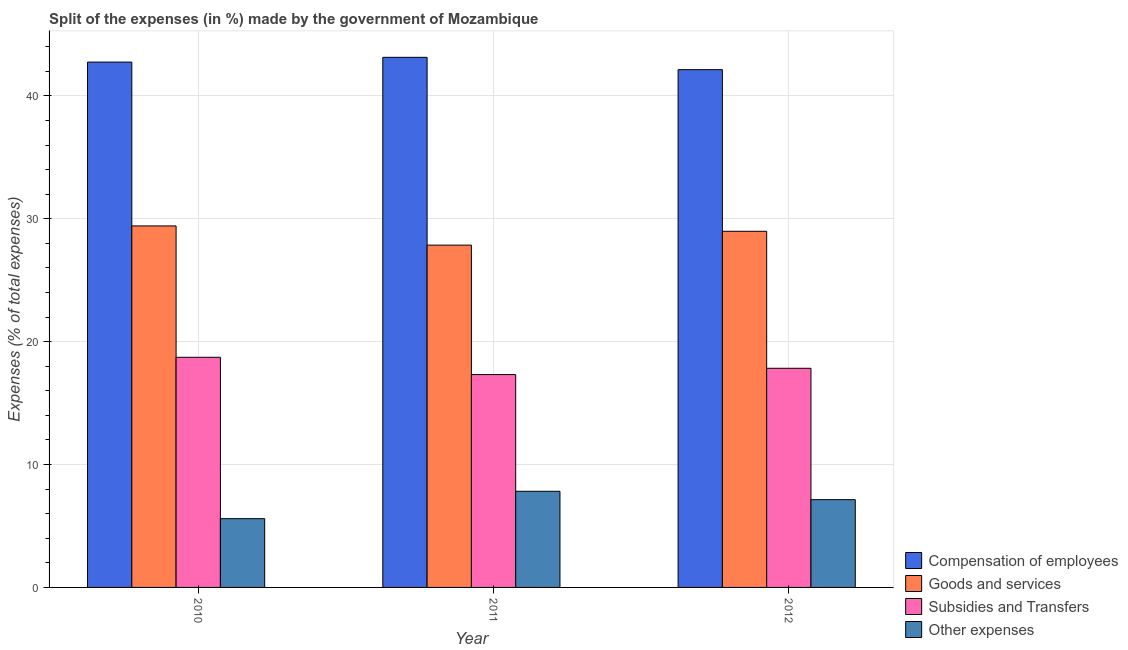How many groups of bars are there?
Keep it short and to the point. 3. Are the number of bars per tick equal to the number of legend labels?
Your answer should be compact. Yes. What is the label of the 1st group of bars from the left?
Provide a short and direct response. 2010. What is the percentage of amount spent on compensation of employees in 2012?
Keep it short and to the point. 42.13. Across all years, what is the maximum percentage of amount spent on subsidies?
Provide a succinct answer. 18.73. Across all years, what is the minimum percentage of amount spent on subsidies?
Your answer should be very brief. 17.32. In which year was the percentage of amount spent on subsidies maximum?
Provide a short and direct response. 2010. What is the total percentage of amount spent on other expenses in the graph?
Your answer should be very brief. 20.56. What is the difference between the percentage of amount spent on compensation of employees in 2010 and that in 2011?
Ensure brevity in your answer.  -0.39. What is the difference between the percentage of amount spent on subsidies in 2012 and the percentage of amount spent on goods and services in 2011?
Provide a succinct answer. 0.51. What is the average percentage of amount spent on subsidies per year?
Keep it short and to the point. 17.96. In how many years, is the percentage of amount spent on other expenses greater than 38 %?
Provide a succinct answer. 0. What is the ratio of the percentage of amount spent on subsidies in 2010 to that in 2012?
Provide a short and direct response. 1.05. Is the percentage of amount spent on subsidies in 2011 less than that in 2012?
Provide a succinct answer. Yes. What is the difference between the highest and the second highest percentage of amount spent on other expenses?
Your response must be concise. 0.68. What is the difference between the highest and the lowest percentage of amount spent on other expenses?
Your answer should be compact. 2.23. In how many years, is the percentage of amount spent on goods and services greater than the average percentage of amount spent on goods and services taken over all years?
Make the answer very short. 2. Is the sum of the percentage of amount spent on subsidies in 2010 and 2012 greater than the maximum percentage of amount spent on other expenses across all years?
Keep it short and to the point. Yes. What does the 4th bar from the left in 2011 represents?
Give a very brief answer. Other expenses. What does the 1st bar from the right in 2012 represents?
Your answer should be compact. Other expenses. How many years are there in the graph?
Provide a short and direct response. 3. Are the values on the major ticks of Y-axis written in scientific E-notation?
Your response must be concise. No. Does the graph contain grids?
Offer a terse response. Yes. Where does the legend appear in the graph?
Provide a short and direct response. Bottom right. How are the legend labels stacked?
Provide a short and direct response. Vertical. What is the title of the graph?
Offer a terse response. Split of the expenses (in %) made by the government of Mozambique. What is the label or title of the X-axis?
Ensure brevity in your answer.  Year. What is the label or title of the Y-axis?
Your response must be concise. Expenses (% of total expenses). What is the Expenses (% of total expenses) of Compensation of employees in 2010?
Offer a terse response. 42.75. What is the Expenses (% of total expenses) in Goods and services in 2010?
Your answer should be compact. 29.42. What is the Expenses (% of total expenses) of Subsidies and Transfers in 2010?
Your answer should be compact. 18.73. What is the Expenses (% of total expenses) of Other expenses in 2010?
Offer a very short reply. 5.6. What is the Expenses (% of total expenses) of Compensation of employees in 2011?
Provide a short and direct response. 43.13. What is the Expenses (% of total expenses) of Goods and services in 2011?
Make the answer very short. 27.85. What is the Expenses (% of total expenses) in Subsidies and Transfers in 2011?
Your answer should be very brief. 17.32. What is the Expenses (% of total expenses) of Other expenses in 2011?
Keep it short and to the point. 7.82. What is the Expenses (% of total expenses) in Compensation of employees in 2012?
Give a very brief answer. 42.13. What is the Expenses (% of total expenses) in Goods and services in 2012?
Your response must be concise. 28.98. What is the Expenses (% of total expenses) in Subsidies and Transfers in 2012?
Offer a terse response. 17.83. What is the Expenses (% of total expenses) of Other expenses in 2012?
Keep it short and to the point. 7.14. Across all years, what is the maximum Expenses (% of total expenses) in Compensation of employees?
Provide a succinct answer. 43.13. Across all years, what is the maximum Expenses (% of total expenses) in Goods and services?
Keep it short and to the point. 29.42. Across all years, what is the maximum Expenses (% of total expenses) of Subsidies and Transfers?
Keep it short and to the point. 18.73. Across all years, what is the maximum Expenses (% of total expenses) in Other expenses?
Offer a terse response. 7.82. Across all years, what is the minimum Expenses (% of total expenses) of Compensation of employees?
Give a very brief answer. 42.13. Across all years, what is the minimum Expenses (% of total expenses) in Goods and services?
Offer a very short reply. 27.85. Across all years, what is the minimum Expenses (% of total expenses) of Subsidies and Transfers?
Offer a very short reply. 17.32. Across all years, what is the minimum Expenses (% of total expenses) of Other expenses?
Provide a short and direct response. 5.6. What is the total Expenses (% of total expenses) in Compensation of employees in the graph?
Your answer should be very brief. 128.01. What is the total Expenses (% of total expenses) of Goods and services in the graph?
Provide a succinct answer. 86.25. What is the total Expenses (% of total expenses) of Subsidies and Transfers in the graph?
Your answer should be very brief. 53.88. What is the total Expenses (% of total expenses) of Other expenses in the graph?
Your response must be concise. 20.56. What is the difference between the Expenses (% of total expenses) in Compensation of employees in 2010 and that in 2011?
Keep it short and to the point. -0.39. What is the difference between the Expenses (% of total expenses) of Goods and services in 2010 and that in 2011?
Your response must be concise. 1.56. What is the difference between the Expenses (% of total expenses) in Subsidies and Transfers in 2010 and that in 2011?
Offer a very short reply. 1.41. What is the difference between the Expenses (% of total expenses) in Other expenses in 2010 and that in 2011?
Offer a very short reply. -2.23. What is the difference between the Expenses (% of total expenses) in Compensation of employees in 2010 and that in 2012?
Offer a terse response. 0.62. What is the difference between the Expenses (% of total expenses) in Goods and services in 2010 and that in 2012?
Ensure brevity in your answer.  0.44. What is the difference between the Expenses (% of total expenses) in Subsidies and Transfers in 2010 and that in 2012?
Your answer should be compact. 0.89. What is the difference between the Expenses (% of total expenses) of Other expenses in 2010 and that in 2012?
Provide a succinct answer. -1.55. What is the difference between the Expenses (% of total expenses) of Goods and services in 2011 and that in 2012?
Your answer should be compact. -1.13. What is the difference between the Expenses (% of total expenses) in Subsidies and Transfers in 2011 and that in 2012?
Your response must be concise. -0.51. What is the difference between the Expenses (% of total expenses) of Other expenses in 2011 and that in 2012?
Your answer should be very brief. 0.68. What is the difference between the Expenses (% of total expenses) in Compensation of employees in 2010 and the Expenses (% of total expenses) in Goods and services in 2011?
Your response must be concise. 14.89. What is the difference between the Expenses (% of total expenses) of Compensation of employees in 2010 and the Expenses (% of total expenses) of Subsidies and Transfers in 2011?
Offer a very short reply. 25.43. What is the difference between the Expenses (% of total expenses) in Compensation of employees in 2010 and the Expenses (% of total expenses) in Other expenses in 2011?
Your answer should be compact. 34.92. What is the difference between the Expenses (% of total expenses) of Goods and services in 2010 and the Expenses (% of total expenses) of Subsidies and Transfers in 2011?
Your answer should be very brief. 12.1. What is the difference between the Expenses (% of total expenses) in Goods and services in 2010 and the Expenses (% of total expenses) in Other expenses in 2011?
Provide a succinct answer. 21.59. What is the difference between the Expenses (% of total expenses) in Subsidies and Transfers in 2010 and the Expenses (% of total expenses) in Other expenses in 2011?
Ensure brevity in your answer.  10.9. What is the difference between the Expenses (% of total expenses) in Compensation of employees in 2010 and the Expenses (% of total expenses) in Goods and services in 2012?
Your answer should be very brief. 13.77. What is the difference between the Expenses (% of total expenses) of Compensation of employees in 2010 and the Expenses (% of total expenses) of Subsidies and Transfers in 2012?
Ensure brevity in your answer.  24.92. What is the difference between the Expenses (% of total expenses) in Compensation of employees in 2010 and the Expenses (% of total expenses) in Other expenses in 2012?
Make the answer very short. 35.61. What is the difference between the Expenses (% of total expenses) of Goods and services in 2010 and the Expenses (% of total expenses) of Subsidies and Transfers in 2012?
Provide a succinct answer. 11.58. What is the difference between the Expenses (% of total expenses) of Goods and services in 2010 and the Expenses (% of total expenses) of Other expenses in 2012?
Offer a terse response. 22.27. What is the difference between the Expenses (% of total expenses) in Subsidies and Transfers in 2010 and the Expenses (% of total expenses) in Other expenses in 2012?
Give a very brief answer. 11.59. What is the difference between the Expenses (% of total expenses) of Compensation of employees in 2011 and the Expenses (% of total expenses) of Goods and services in 2012?
Offer a terse response. 14.15. What is the difference between the Expenses (% of total expenses) of Compensation of employees in 2011 and the Expenses (% of total expenses) of Subsidies and Transfers in 2012?
Provide a short and direct response. 25.3. What is the difference between the Expenses (% of total expenses) in Compensation of employees in 2011 and the Expenses (% of total expenses) in Other expenses in 2012?
Offer a terse response. 35.99. What is the difference between the Expenses (% of total expenses) in Goods and services in 2011 and the Expenses (% of total expenses) in Subsidies and Transfers in 2012?
Make the answer very short. 10.02. What is the difference between the Expenses (% of total expenses) of Goods and services in 2011 and the Expenses (% of total expenses) of Other expenses in 2012?
Make the answer very short. 20.71. What is the difference between the Expenses (% of total expenses) of Subsidies and Transfers in 2011 and the Expenses (% of total expenses) of Other expenses in 2012?
Your response must be concise. 10.18. What is the average Expenses (% of total expenses) in Compensation of employees per year?
Offer a terse response. 42.67. What is the average Expenses (% of total expenses) of Goods and services per year?
Offer a very short reply. 28.75. What is the average Expenses (% of total expenses) of Subsidies and Transfers per year?
Give a very brief answer. 17.96. What is the average Expenses (% of total expenses) of Other expenses per year?
Ensure brevity in your answer.  6.85. In the year 2010, what is the difference between the Expenses (% of total expenses) of Compensation of employees and Expenses (% of total expenses) of Goods and services?
Ensure brevity in your answer.  13.33. In the year 2010, what is the difference between the Expenses (% of total expenses) in Compensation of employees and Expenses (% of total expenses) in Subsidies and Transfers?
Give a very brief answer. 24.02. In the year 2010, what is the difference between the Expenses (% of total expenses) of Compensation of employees and Expenses (% of total expenses) of Other expenses?
Your answer should be compact. 37.15. In the year 2010, what is the difference between the Expenses (% of total expenses) in Goods and services and Expenses (% of total expenses) in Subsidies and Transfers?
Give a very brief answer. 10.69. In the year 2010, what is the difference between the Expenses (% of total expenses) of Goods and services and Expenses (% of total expenses) of Other expenses?
Provide a short and direct response. 23.82. In the year 2010, what is the difference between the Expenses (% of total expenses) in Subsidies and Transfers and Expenses (% of total expenses) in Other expenses?
Ensure brevity in your answer.  13.13. In the year 2011, what is the difference between the Expenses (% of total expenses) of Compensation of employees and Expenses (% of total expenses) of Goods and services?
Ensure brevity in your answer.  15.28. In the year 2011, what is the difference between the Expenses (% of total expenses) of Compensation of employees and Expenses (% of total expenses) of Subsidies and Transfers?
Offer a terse response. 25.81. In the year 2011, what is the difference between the Expenses (% of total expenses) of Compensation of employees and Expenses (% of total expenses) of Other expenses?
Ensure brevity in your answer.  35.31. In the year 2011, what is the difference between the Expenses (% of total expenses) of Goods and services and Expenses (% of total expenses) of Subsidies and Transfers?
Make the answer very short. 10.53. In the year 2011, what is the difference between the Expenses (% of total expenses) in Goods and services and Expenses (% of total expenses) in Other expenses?
Your answer should be compact. 20.03. In the year 2011, what is the difference between the Expenses (% of total expenses) of Subsidies and Transfers and Expenses (% of total expenses) of Other expenses?
Ensure brevity in your answer.  9.5. In the year 2012, what is the difference between the Expenses (% of total expenses) in Compensation of employees and Expenses (% of total expenses) in Goods and services?
Ensure brevity in your answer.  13.15. In the year 2012, what is the difference between the Expenses (% of total expenses) of Compensation of employees and Expenses (% of total expenses) of Subsidies and Transfers?
Offer a terse response. 24.3. In the year 2012, what is the difference between the Expenses (% of total expenses) in Compensation of employees and Expenses (% of total expenses) in Other expenses?
Your answer should be compact. 34.99. In the year 2012, what is the difference between the Expenses (% of total expenses) of Goods and services and Expenses (% of total expenses) of Subsidies and Transfers?
Offer a terse response. 11.15. In the year 2012, what is the difference between the Expenses (% of total expenses) in Goods and services and Expenses (% of total expenses) in Other expenses?
Provide a short and direct response. 21.84. In the year 2012, what is the difference between the Expenses (% of total expenses) of Subsidies and Transfers and Expenses (% of total expenses) of Other expenses?
Your response must be concise. 10.69. What is the ratio of the Expenses (% of total expenses) in Goods and services in 2010 to that in 2011?
Your answer should be very brief. 1.06. What is the ratio of the Expenses (% of total expenses) of Subsidies and Transfers in 2010 to that in 2011?
Your answer should be very brief. 1.08. What is the ratio of the Expenses (% of total expenses) of Other expenses in 2010 to that in 2011?
Provide a succinct answer. 0.72. What is the ratio of the Expenses (% of total expenses) in Compensation of employees in 2010 to that in 2012?
Make the answer very short. 1.01. What is the ratio of the Expenses (% of total expenses) of Goods and services in 2010 to that in 2012?
Your response must be concise. 1.01. What is the ratio of the Expenses (% of total expenses) of Subsidies and Transfers in 2010 to that in 2012?
Provide a short and direct response. 1.05. What is the ratio of the Expenses (% of total expenses) of Other expenses in 2010 to that in 2012?
Provide a succinct answer. 0.78. What is the ratio of the Expenses (% of total expenses) of Compensation of employees in 2011 to that in 2012?
Offer a terse response. 1.02. What is the ratio of the Expenses (% of total expenses) in Goods and services in 2011 to that in 2012?
Make the answer very short. 0.96. What is the ratio of the Expenses (% of total expenses) of Subsidies and Transfers in 2011 to that in 2012?
Provide a succinct answer. 0.97. What is the ratio of the Expenses (% of total expenses) in Other expenses in 2011 to that in 2012?
Give a very brief answer. 1.1. What is the difference between the highest and the second highest Expenses (% of total expenses) of Compensation of employees?
Make the answer very short. 0.39. What is the difference between the highest and the second highest Expenses (% of total expenses) in Goods and services?
Give a very brief answer. 0.44. What is the difference between the highest and the second highest Expenses (% of total expenses) of Subsidies and Transfers?
Offer a very short reply. 0.89. What is the difference between the highest and the second highest Expenses (% of total expenses) of Other expenses?
Keep it short and to the point. 0.68. What is the difference between the highest and the lowest Expenses (% of total expenses) of Goods and services?
Keep it short and to the point. 1.56. What is the difference between the highest and the lowest Expenses (% of total expenses) of Subsidies and Transfers?
Offer a very short reply. 1.41. What is the difference between the highest and the lowest Expenses (% of total expenses) of Other expenses?
Your response must be concise. 2.23. 